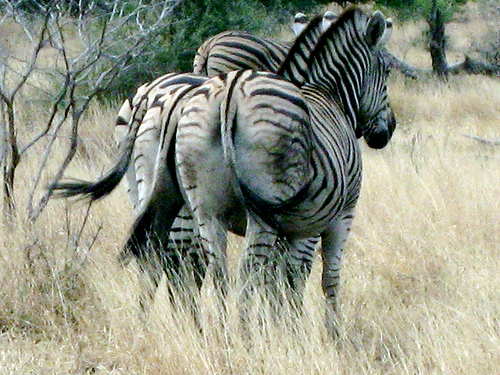Are the patterns on zebras of any specific use to them? Indeed, the striking patterns on a zebra are believed to serve several functions. They may be used for camouflage in long grass, to confuse predators, to regulate body temperature, or even to help zebras recognize one another. 